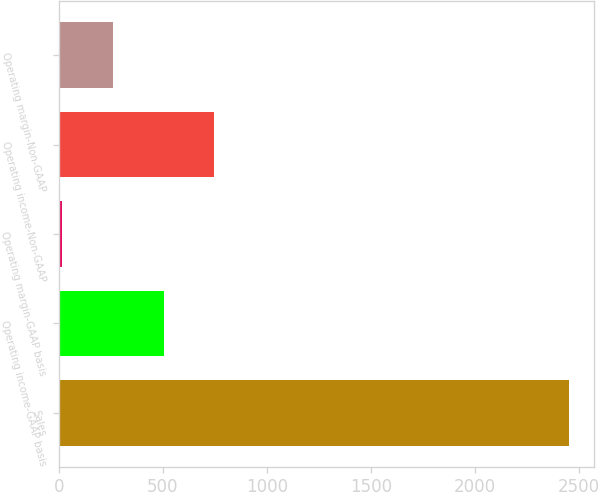Convert chart to OTSL. <chart><loc_0><loc_0><loc_500><loc_500><bar_chart><fcel>Sales<fcel>Operating income-GAAP basis<fcel>Operating margin-GAAP basis<fcel>Operating income-Non-GAAP<fcel>Operating margin-Non-GAAP<nl><fcel>2449<fcel>503.72<fcel>17.4<fcel>746.88<fcel>260.56<nl></chart> 